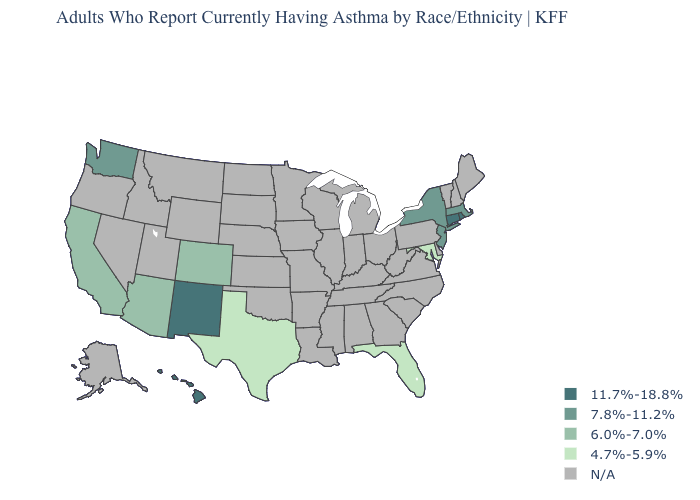What is the value of Montana?
Write a very short answer. N/A. What is the value of Wisconsin?
Concise answer only. N/A. What is the value of Mississippi?
Concise answer only. N/A. Does New Jersey have the lowest value in the USA?
Short answer required. No. Name the states that have a value in the range 7.8%-11.2%?
Short answer required. Massachusetts, New Jersey, New York, Washington. Which states have the lowest value in the USA?
Quick response, please. Florida, Maryland, Texas. What is the value of New Mexico?
Concise answer only. 11.7%-18.8%. What is the value of Michigan?
Keep it brief. N/A. What is the value of Ohio?
Write a very short answer. N/A. What is the highest value in the West ?
Short answer required. 11.7%-18.8%. What is the value of Massachusetts?
Concise answer only. 7.8%-11.2%. Does Rhode Island have the highest value in the USA?
Answer briefly. Yes. Name the states that have a value in the range N/A?
Short answer required. Alabama, Alaska, Arkansas, Delaware, Georgia, Idaho, Illinois, Indiana, Iowa, Kansas, Kentucky, Louisiana, Maine, Michigan, Minnesota, Mississippi, Missouri, Montana, Nebraska, Nevada, New Hampshire, North Carolina, North Dakota, Ohio, Oklahoma, Oregon, Pennsylvania, South Carolina, South Dakota, Tennessee, Utah, Vermont, Virginia, West Virginia, Wisconsin, Wyoming. What is the highest value in the USA?
Keep it brief. 11.7%-18.8%. 